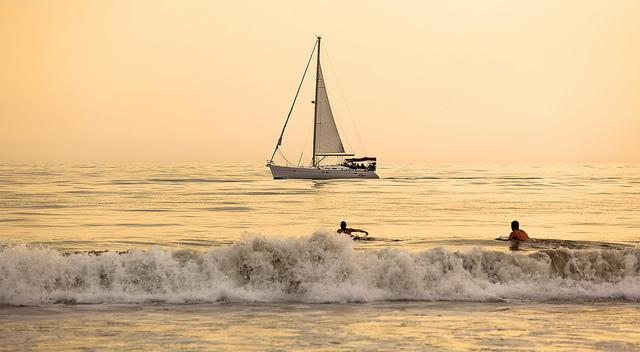What natural feature do the surfers like but the sailors of the boat here hate?

Choices:
A) big waves
B) tornados
C) tidal wave
D) calm waves big waves 